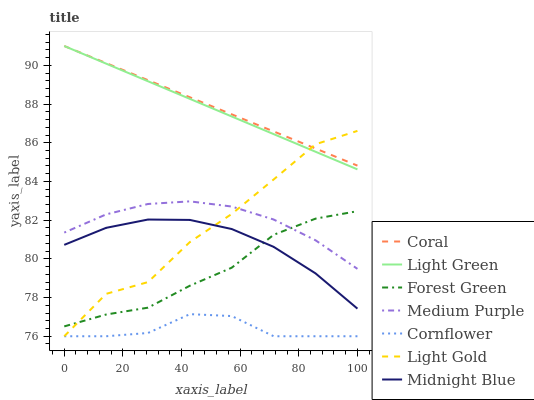Does Cornflower have the minimum area under the curve?
Answer yes or no. Yes. Does Coral have the maximum area under the curve?
Answer yes or no. Yes. Does Midnight Blue have the minimum area under the curve?
Answer yes or no. No. Does Midnight Blue have the maximum area under the curve?
Answer yes or no. No. Is Coral the smoothest?
Answer yes or no. Yes. Is Light Gold the roughest?
Answer yes or no. Yes. Is Midnight Blue the smoothest?
Answer yes or no. No. Is Midnight Blue the roughest?
Answer yes or no. No. Does Cornflower have the lowest value?
Answer yes or no. Yes. Does Midnight Blue have the lowest value?
Answer yes or no. No. Does Light Green have the highest value?
Answer yes or no. Yes. Does Midnight Blue have the highest value?
Answer yes or no. No. Is Cornflower less than Midnight Blue?
Answer yes or no. Yes. Is Coral greater than Midnight Blue?
Answer yes or no. Yes. Does Medium Purple intersect Forest Green?
Answer yes or no. Yes. Is Medium Purple less than Forest Green?
Answer yes or no. No. Is Medium Purple greater than Forest Green?
Answer yes or no. No. Does Cornflower intersect Midnight Blue?
Answer yes or no. No. 